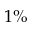Convert formula to latex. <formula><loc_0><loc_0><loc_500><loc_500>1 \%</formula> 